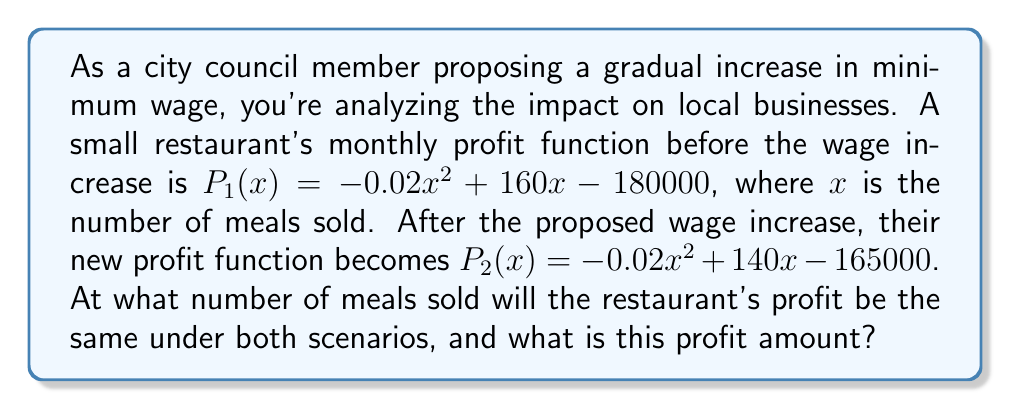Give your solution to this math problem. To solve this problem, we need to find the intersection point(s) of the two polynomial functions $P_1(x)$ and $P_2(x)$. This point represents the break-even point where the profit is the same under both wage scenarios.

Step 1: Set up the equation
$$P_1(x) = P_2(x)$$
$$-0.02x^2 + 160x - 180000 = -0.02x^2 + 140x - 165000$$

Step 2: Simplify the equation
The $-0.02x^2$ terms cancel out on both sides:
$$160x - 180000 = 140x - 165000$$

Step 3: Solve for x
$$160x - 140x = 180000 - 165000$$
$$20x = 15000$$
$$x = 750$$

Step 4: Calculate the profit at this point by substituting x = 750 into either $P_1(x)$ or $P_2(x)$
Let's use $P_1(x)$:
$$P_1(750) = -0.02(750)^2 + 160(750) - 180000$$
$$= -0.02(562500) + 120000 - 180000$$
$$= -11250 + 120000 - 180000$$
$$= -71250$$

Therefore, the restaurant's profit will be the same under both scenarios when 750 meals are sold, and the profit at this point is $-71,250.
Answer: 750 meals; $-71,250 